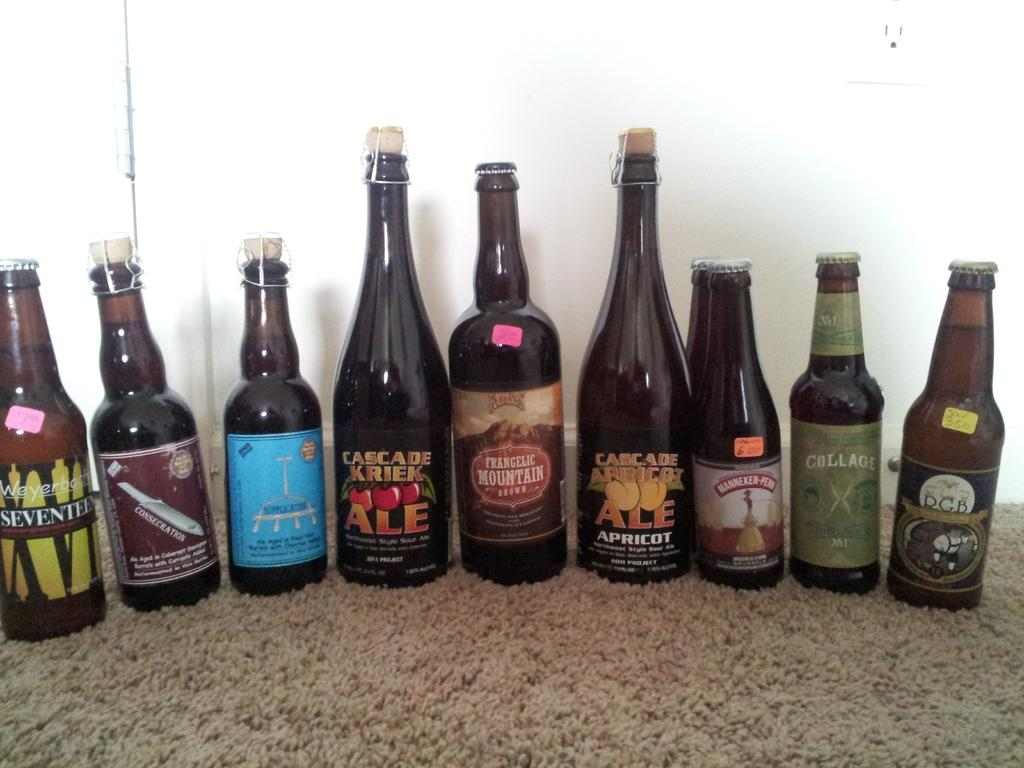<image>
Describe the image concisely. Bottles of beer including Cascade Kriek ale on a carpet. 